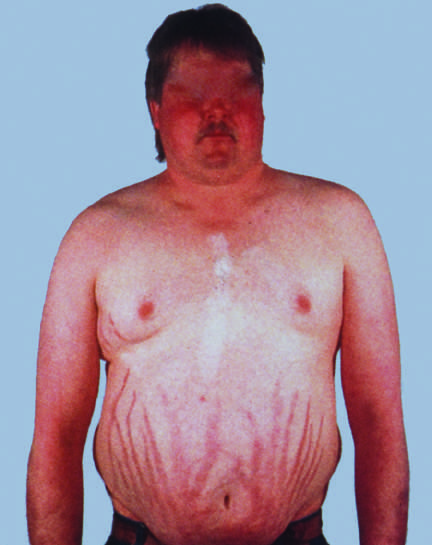what do characteristic features include?
Answer the question using a single word or phrase. Central obesity 